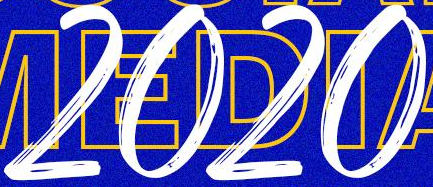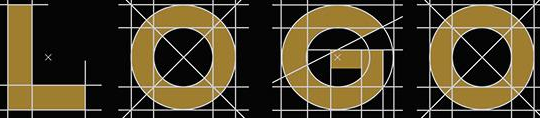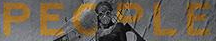Identify the words shown in these images in order, separated by a semicolon. 2020; LOGO; PEOPLE 